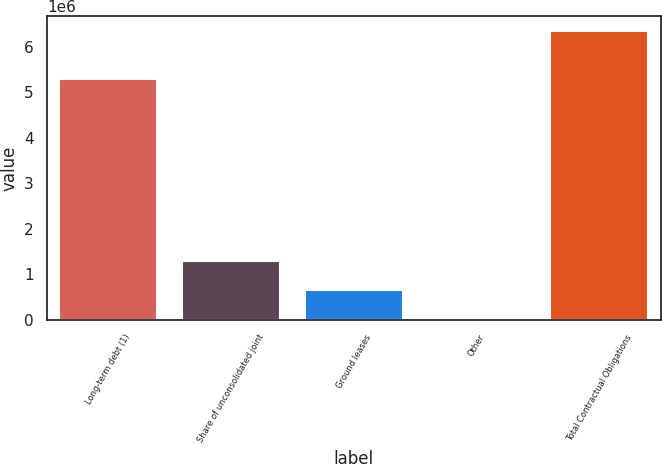Convert chart. <chart><loc_0><loc_0><loc_500><loc_500><bar_chart><fcel>Long-term debt (1)<fcel>Share of unconsolidated joint<fcel>Ground leases<fcel>Other<fcel>Total Contractual Obligations<nl><fcel>5.3029e+06<fcel>1.28667e+06<fcel>652574<fcel>18482<fcel>6.3594e+06<nl></chart> 